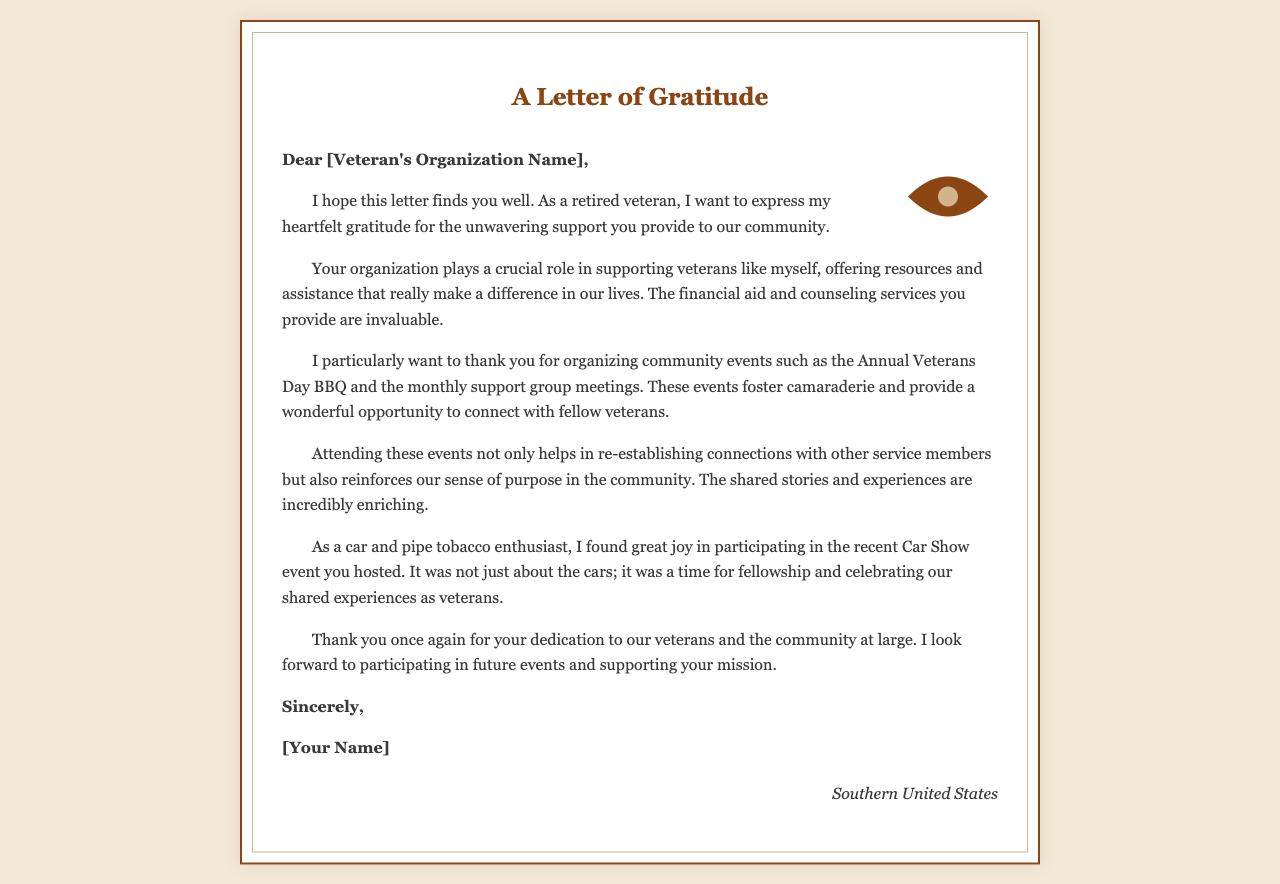What is the name of the event mentioned in the letter? The letter references community events hosted by the organization, specifically naming the Annual Veterans Day BBQ.
Answer: Annual Veterans Day BBQ Who is the intended recipient of the letter? The salutation addresses the letter to a specific group, indicated as "[Veteran's Organization Name]."
Answer: [Veteran's Organization Name] What does the author express gratitude for? The letter highlights gratitude for resources and support provided by the organization to veterans, including financial aid and counseling.
Answer: unwavering support What is one of the author's hobbies mentioned in the letter? The letter mentions the author's involvement with cars, indicating enjoyment in participating in related events.
Answer: car What is the location mentioned at the end of the letter? The letter concludes with a location where the author resides, which is stated as the Southern United States.
Answer: Southern United States How does the author feel about the community events? The author expresses a positive sentiment towards attending the events, emphasizing their importance for camaraderie and connection.
Answer: helps in re-establishing connections What does "the shared stories and experiences" refer to? This phrase in the letter discusses the enriching aspect of attending events and connecting with fellow veterans.
Answer: connecting with fellow veterans What type of document is this? The document is a formal communication expressing gratitude, typically characterized by a specific structure and tone.
Answer: Thank-you letter How does the author sign off the letter? The closing of the letter indicates a formal farewell, and is followed by the author's name.
Answer: Sincerely 